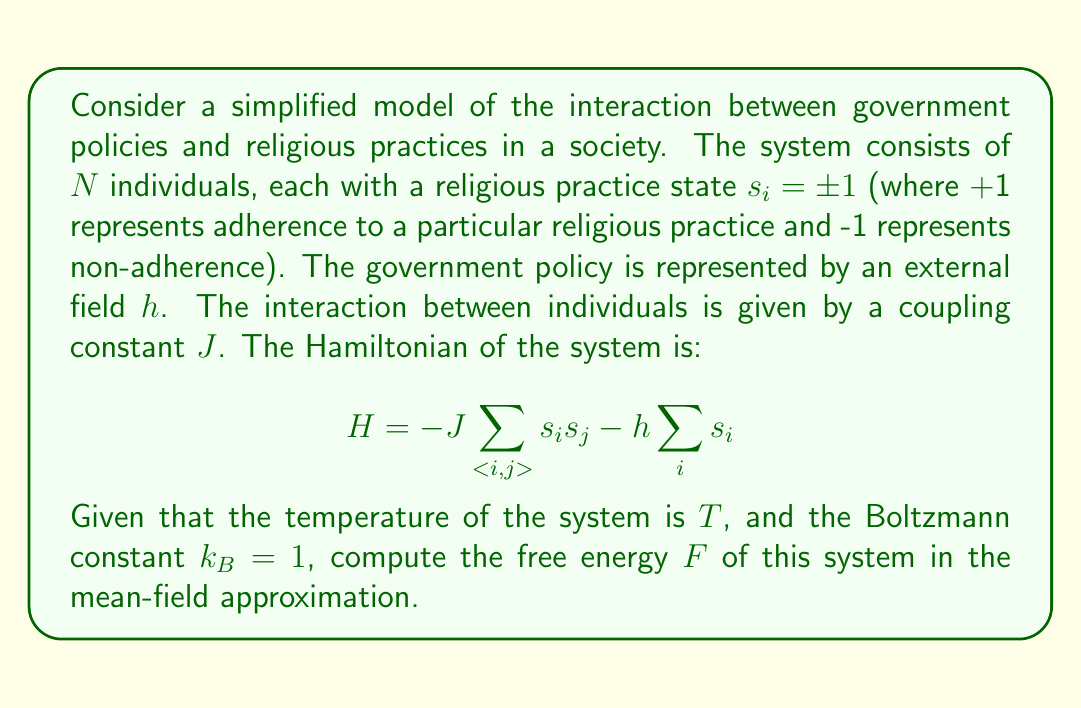Can you answer this question? To solve this problem, we'll use the mean-field approximation and follow these steps:

1) In the mean-field approximation, we assume that each spin interacts with the average spin of the system, $m = \langle s_i \rangle$. The effective field experienced by each spin is:

   $$h_{eff} = h + Jzm$$

   where $z$ is the number of nearest neighbors.

2) The partition function for a single spin in this effective field is:

   $$Z_1 = e^{\beta h_{eff}} + e^{-\beta h_{eff}} = 2\cosh(\beta h_{eff})$$

   where $\beta = \frac{1}{k_BT} = \frac{1}{T}$ (since $k_B = 1$).

3) The free energy per spin is:

   $$f = -\frac{1}{\beta}\ln Z_1 - \frac{1}{2}Jzm^2$$

   The second term corrects for double-counting of interactions.

4) Substituting the expression for $Z_1$:

   $$f = -\frac{1}{\beta}\ln[2\cosh(\beta(h + Jzm))] - \frac{1}{2}Jzm^2$$

5) The total free energy for $N$ spins is:

   $$F = Nf = -\frac{N}{\beta}\ln[2\cosh(\beta(h + Jzm))] - \frac{1}{2}NJzm^2$$

6) To find $m$, we minimize $f$ with respect to $m$:

   $$\frac{\partial f}{\partial m} = -Jz\tanh(\beta(h + Jzm)) - Jzm = 0$$

   This gives the self-consistent equation:

   $$m = \tanh(\beta(h + Jzm))$$

7) Solve this equation numerically for $m$, then substitute back into the expression for $F$ to get the final result.
Answer: $$F = -\frac{N}{\beta}\ln[2\cosh(\beta(h + Jzm))] - \frac{1}{2}NJzm^2$$
where $m$ satisfies $m = \tanh(\beta(h + Jzm))$ 